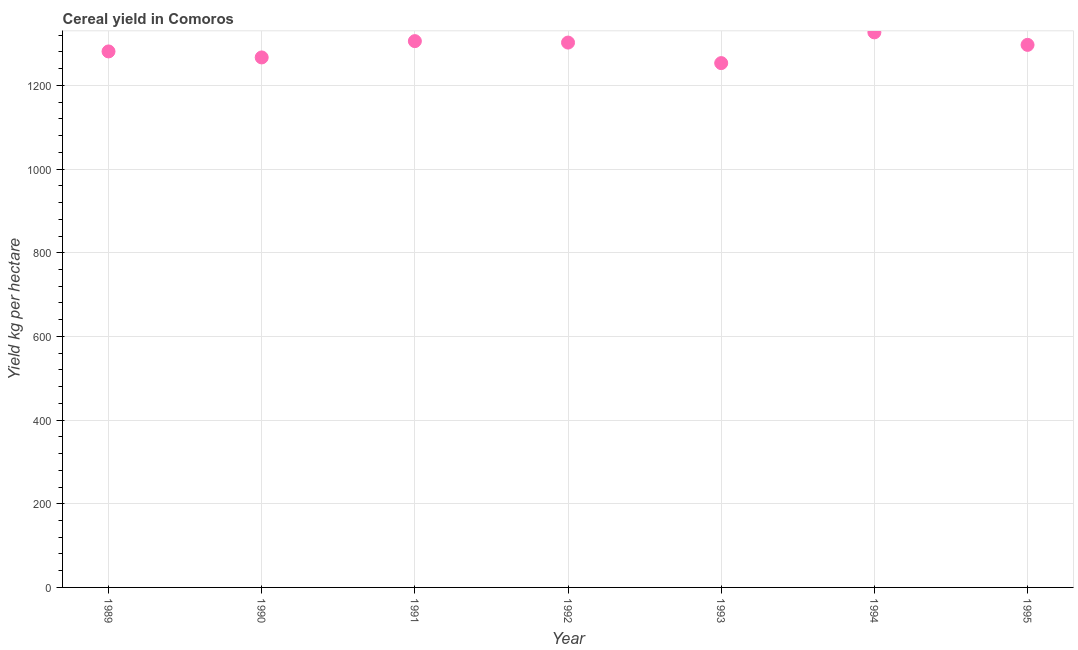What is the cereal yield in 1989?
Make the answer very short. 1281.34. Across all years, what is the maximum cereal yield?
Provide a short and direct response. 1326.92. Across all years, what is the minimum cereal yield?
Offer a terse response. 1253.42. In which year was the cereal yield maximum?
Provide a succinct answer. 1994. In which year was the cereal yield minimum?
Give a very brief answer. 1993. What is the sum of the cereal yield?
Ensure brevity in your answer.  9034.17. What is the difference between the cereal yield in 1990 and 1995?
Your answer should be very brief. -30.03. What is the average cereal yield per year?
Offer a terse response. 1290.6. What is the median cereal yield?
Make the answer very short. 1297.01. In how many years, is the cereal yield greater than 840 kg per hectare?
Provide a succinct answer. 7. What is the ratio of the cereal yield in 1991 to that in 1992?
Make the answer very short. 1. What is the difference between the highest and the second highest cereal yield?
Give a very brief answer. 20.95. What is the difference between the highest and the lowest cereal yield?
Offer a very short reply. 73.5. How many dotlines are there?
Give a very brief answer. 1. Are the values on the major ticks of Y-axis written in scientific E-notation?
Provide a short and direct response. No. What is the title of the graph?
Offer a terse response. Cereal yield in Comoros. What is the label or title of the Y-axis?
Offer a very short reply. Yield kg per hectare. What is the Yield kg per hectare in 1989?
Offer a terse response. 1281.34. What is the Yield kg per hectare in 1990?
Keep it short and to the point. 1266.98. What is the Yield kg per hectare in 1991?
Offer a very short reply. 1305.97. What is the Yield kg per hectare in 1992?
Make the answer very short. 1302.52. What is the Yield kg per hectare in 1993?
Provide a short and direct response. 1253.42. What is the Yield kg per hectare in 1994?
Offer a very short reply. 1326.92. What is the Yield kg per hectare in 1995?
Give a very brief answer. 1297.01. What is the difference between the Yield kg per hectare in 1989 and 1990?
Provide a short and direct response. 14.36. What is the difference between the Yield kg per hectare in 1989 and 1991?
Your answer should be compact. -24.63. What is the difference between the Yield kg per hectare in 1989 and 1992?
Provide a succinct answer. -21.17. What is the difference between the Yield kg per hectare in 1989 and 1993?
Offer a terse response. 27.92. What is the difference between the Yield kg per hectare in 1989 and 1994?
Make the answer very short. -45.58. What is the difference between the Yield kg per hectare in 1989 and 1995?
Offer a very short reply. -15.67. What is the difference between the Yield kg per hectare in 1990 and 1991?
Your response must be concise. -38.99. What is the difference between the Yield kg per hectare in 1990 and 1992?
Provide a short and direct response. -35.54. What is the difference between the Yield kg per hectare in 1990 and 1993?
Make the answer very short. 13.56. What is the difference between the Yield kg per hectare in 1990 and 1994?
Offer a very short reply. -59.94. What is the difference between the Yield kg per hectare in 1990 and 1995?
Your answer should be very brief. -30.03. What is the difference between the Yield kg per hectare in 1991 and 1992?
Provide a short and direct response. 3.46. What is the difference between the Yield kg per hectare in 1991 and 1993?
Give a very brief answer. 52.55. What is the difference between the Yield kg per hectare in 1991 and 1994?
Offer a very short reply. -20.95. What is the difference between the Yield kg per hectare in 1991 and 1995?
Your answer should be very brief. 8.96. What is the difference between the Yield kg per hectare in 1992 and 1993?
Offer a very short reply. 49.09. What is the difference between the Yield kg per hectare in 1992 and 1994?
Provide a succinct answer. -24.41. What is the difference between the Yield kg per hectare in 1992 and 1995?
Offer a terse response. 5.5. What is the difference between the Yield kg per hectare in 1993 and 1994?
Offer a terse response. -73.5. What is the difference between the Yield kg per hectare in 1993 and 1995?
Offer a terse response. -43.59. What is the difference between the Yield kg per hectare in 1994 and 1995?
Keep it short and to the point. 29.91. What is the ratio of the Yield kg per hectare in 1989 to that in 1993?
Provide a short and direct response. 1.02. What is the ratio of the Yield kg per hectare in 1989 to that in 1994?
Your answer should be very brief. 0.97. What is the ratio of the Yield kg per hectare in 1989 to that in 1995?
Your answer should be very brief. 0.99. What is the ratio of the Yield kg per hectare in 1990 to that in 1991?
Offer a very short reply. 0.97. What is the ratio of the Yield kg per hectare in 1990 to that in 1992?
Provide a succinct answer. 0.97. What is the ratio of the Yield kg per hectare in 1990 to that in 1994?
Your response must be concise. 0.95. What is the ratio of the Yield kg per hectare in 1990 to that in 1995?
Your response must be concise. 0.98. What is the ratio of the Yield kg per hectare in 1991 to that in 1992?
Your answer should be very brief. 1. What is the ratio of the Yield kg per hectare in 1991 to that in 1993?
Your response must be concise. 1.04. What is the ratio of the Yield kg per hectare in 1991 to that in 1994?
Your answer should be very brief. 0.98. What is the ratio of the Yield kg per hectare in 1991 to that in 1995?
Offer a terse response. 1.01. What is the ratio of the Yield kg per hectare in 1992 to that in 1993?
Your answer should be compact. 1.04. What is the ratio of the Yield kg per hectare in 1992 to that in 1994?
Your answer should be very brief. 0.98. What is the ratio of the Yield kg per hectare in 1992 to that in 1995?
Offer a terse response. 1. What is the ratio of the Yield kg per hectare in 1993 to that in 1994?
Keep it short and to the point. 0.94. What is the ratio of the Yield kg per hectare in 1993 to that in 1995?
Give a very brief answer. 0.97. What is the ratio of the Yield kg per hectare in 1994 to that in 1995?
Keep it short and to the point. 1.02. 